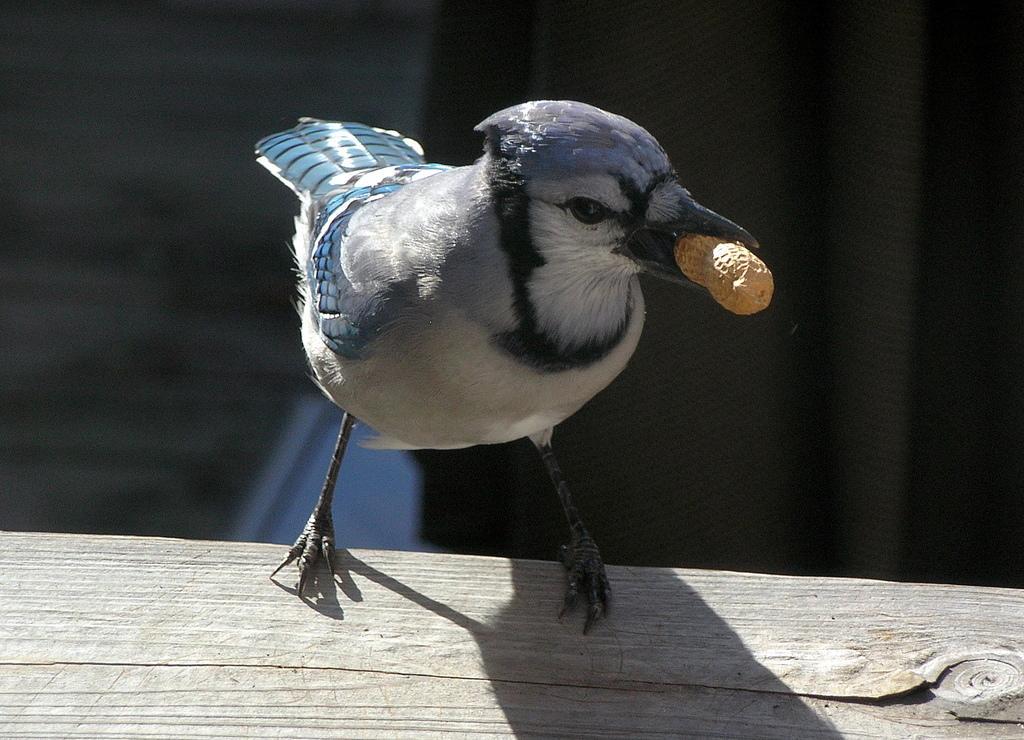Please provide a concise description of this image. In this image, I can see a bird on a wooden object and holding a peanut. There is a blurred background. 